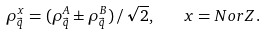<formula> <loc_0><loc_0><loc_500><loc_500>\rho _ { \vec { q } } ^ { x } = ( \rho ^ { A } _ { \vec { q } } \pm \rho ^ { B } _ { \vec { q } } ) \, / \, \sqrt { 2 } , \quad x = N o r Z .</formula> 